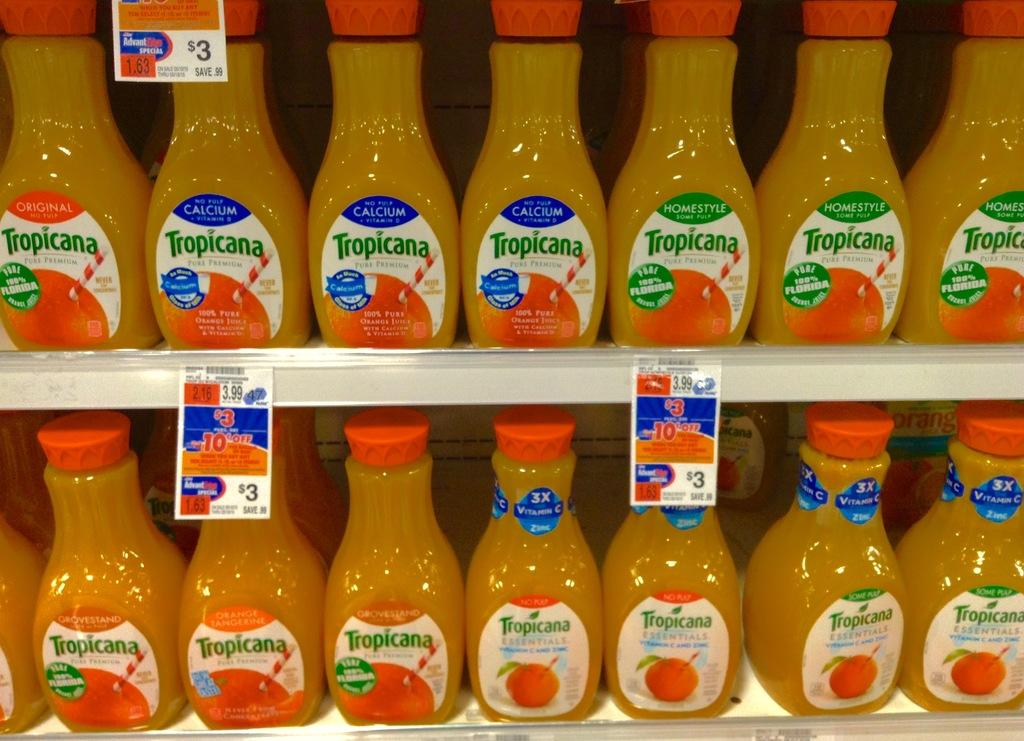<image>
Share a concise interpretation of the image provided. A $3 sale on Tropicana Orange Juice on a store shelf. 